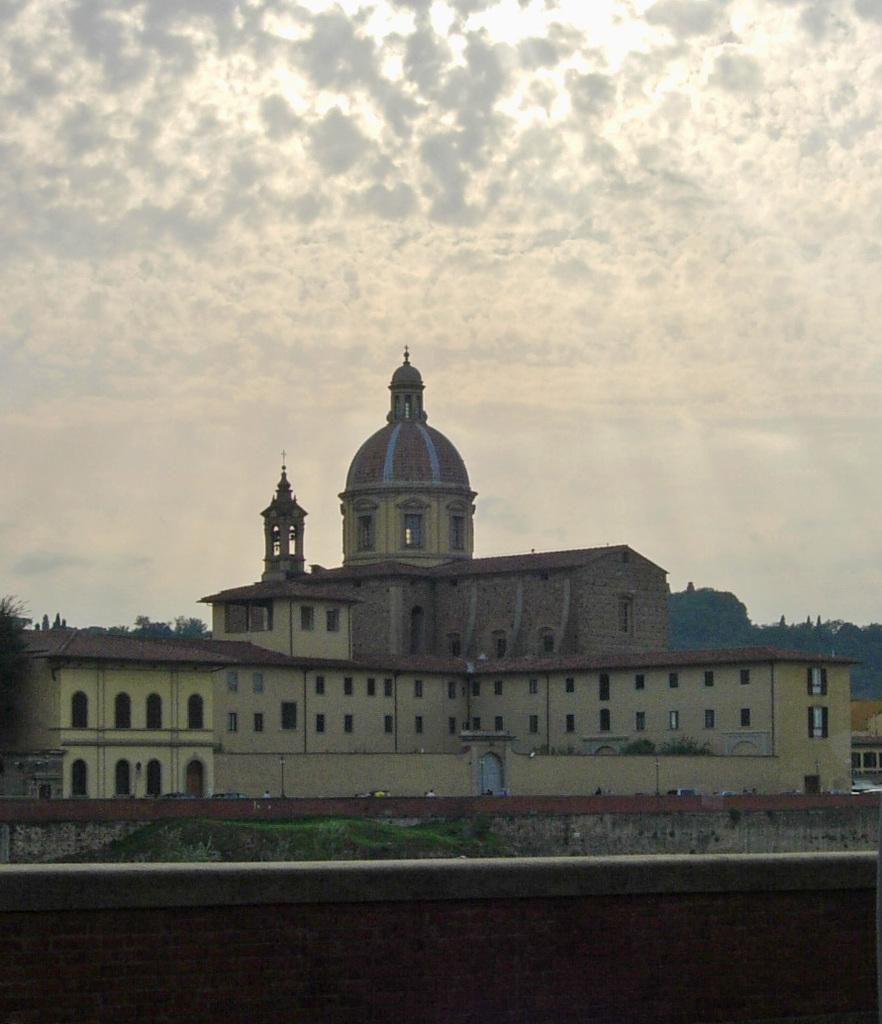What type of structure can be seen in the image? There is a small wall in the image. What else is visible in the background of the image? There is a building and trees in the background of the image. What else can be seen in the sky? The sky is visible in the background of the image. How many mice are sitting on the thumb in the image? There are no mice or thumbs present in the image. 